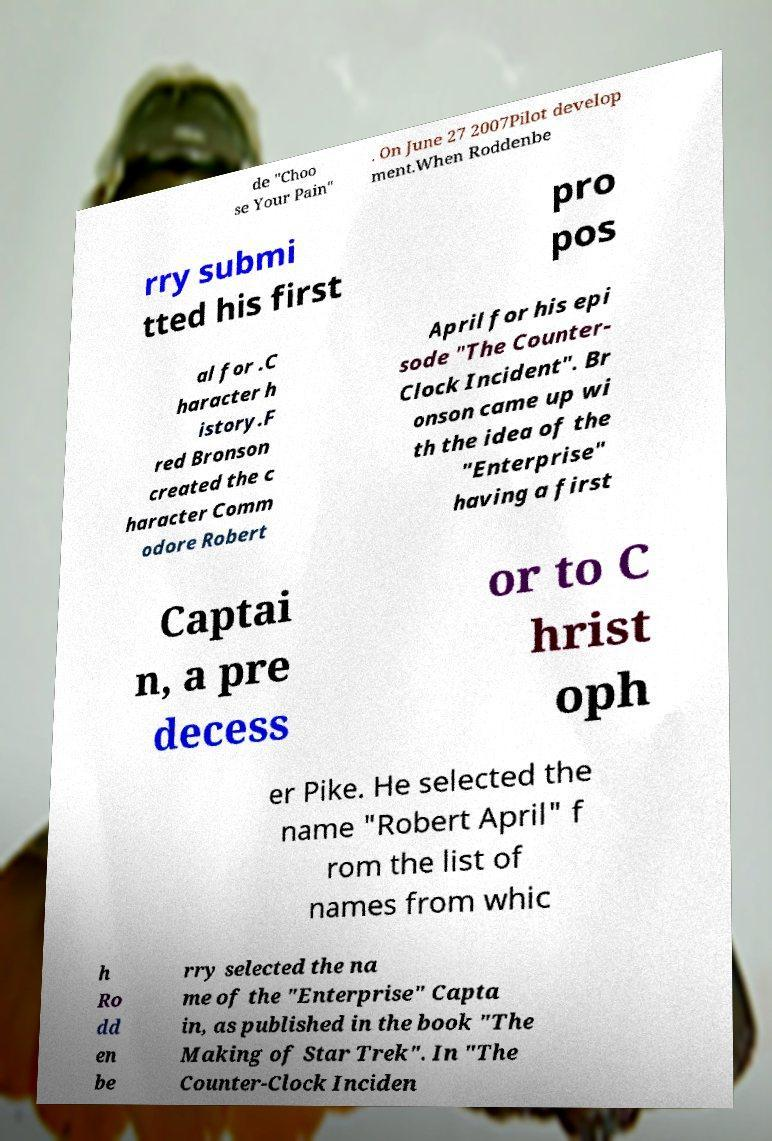For documentation purposes, I need the text within this image transcribed. Could you provide that? de "Choo se Your Pain" . On June 27 2007Pilot develop ment.When Roddenbe rry submi tted his first pro pos al for .C haracter h istory.F red Bronson created the c haracter Comm odore Robert April for his epi sode "The Counter- Clock Incident". Br onson came up wi th the idea of the "Enterprise" having a first Captai n, a pre decess or to C hrist oph er Pike. He selected the name "Robert April" f rom the list of names from whic h Ro dd en be rry selected the na me of the "Enterprise" Capta in, as published in the book "The Making of Star Trek". In "The Counter-Clock Inciden 